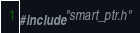<code> <loc_0><loc_0><loc_500><loc_500><_C++_>#include "smart_ptr.h"
</code> 